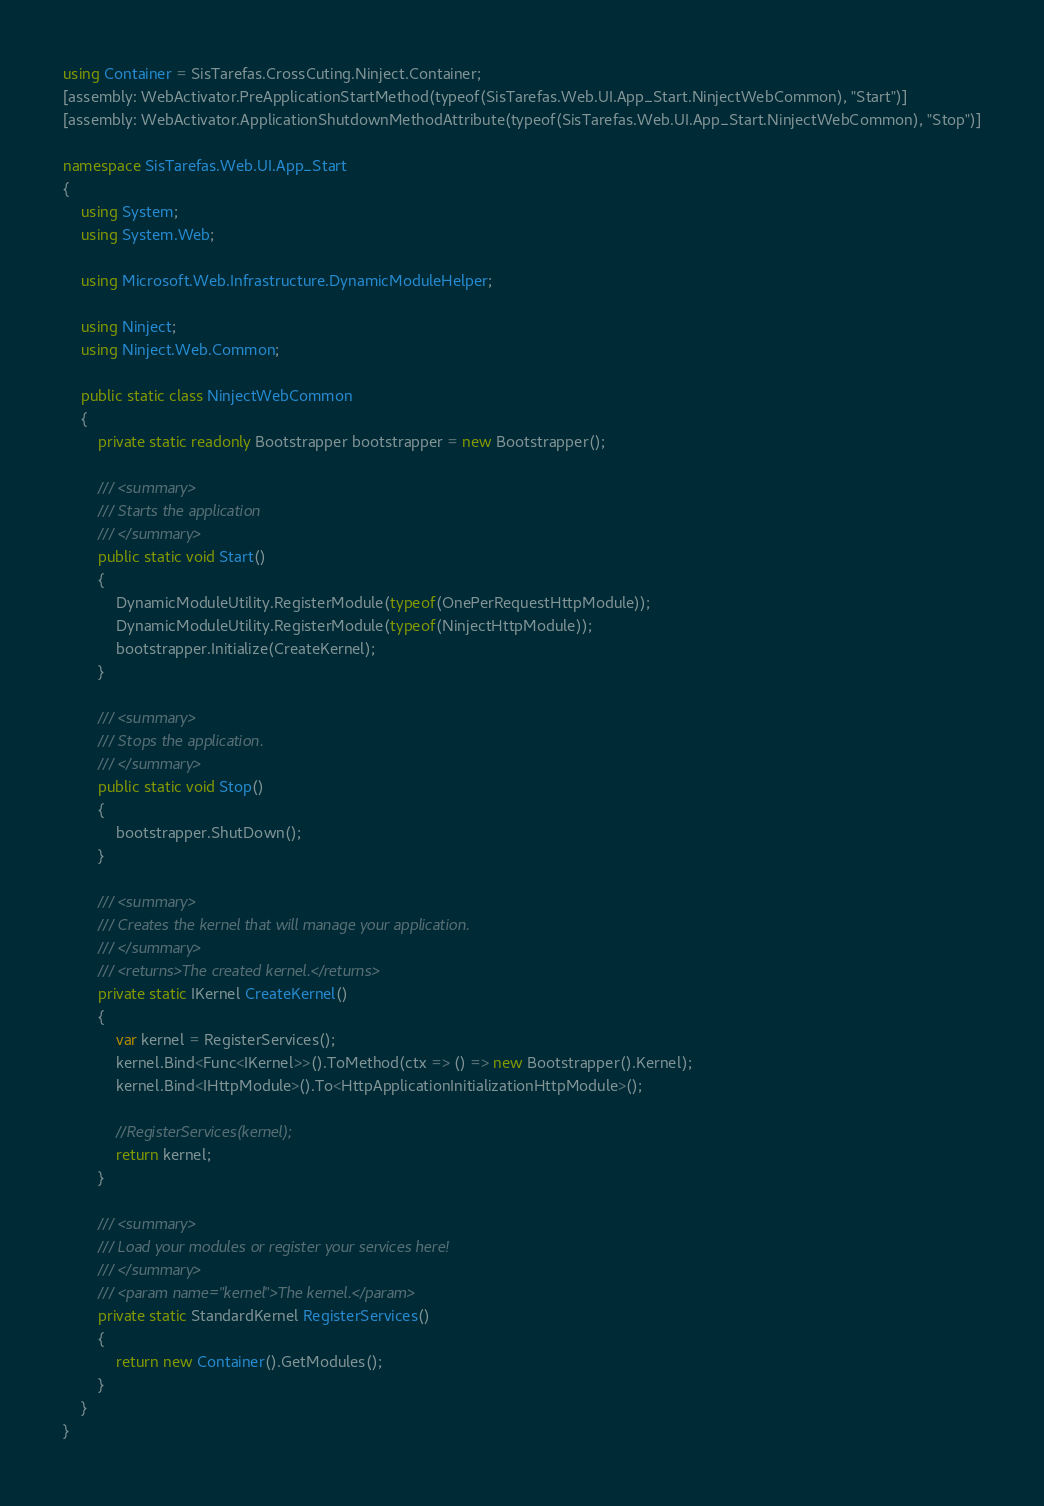<code> <loc_0><loc_0><loc_500><loc_500><_C#_>using Container = SisTarefas.CrossCuting.Ninject.Container;
[assembly: WebActivator.PreApplicationStartMethod(typeof(SisTarefas.Web.UI.App_Start.NinjectWebCommon), "Start")]
[assembly: WebActivator.ApplicationShutdownMethodAttribute(typeof(SisTarefas.Web.UI.App_Start.NinjectWebCommon), "Stop")]

namespace SisTarefas.Web.UI.App_Start
{
    using System;
    using System.Web;

    using Microsoft.Web.Infrastructure.DynamicModuleHelper;

    using Ninject;
    using Ninject.Web.Common;

    public static class NinjectWebCommon 
    {
        private static readonly Bootstrapper bootstrapper = new Bootstrapper();

        /// <summary>
        /// Starts the application
        /// </summary>
        public static void Start() 
        {
            DynamicModuleUtility.RegisterModule(typeof(OnePerRequestHttpModule));
            DynamicModuleUtility.RegisterModule(typeof(NinjectHttpModule));
            bootstrapper.Initialize(CreateKernel);
        }
        
        /// <summary>
        /// Stops the application.
        /// </summary>
        public static void Stop()
        {
            bootstrapper.ShutDown();
        }
        
        /// <summary>
        /// Creates the kernel that will manage your application.
        /// </summary>
        /// <returns>The created kernel.</returns>
        private static IKernel CreateKernel()
        {
            var kernel = RegisterServices();
            kernel.Bind<Func<IKernel>>().ToMethod(ctx => () => new Bootstrapper().Kernel);
            kernel.Bind<IHttpModule>().To<HttpApplicationInitializationHttpModule>();
            
            //RegisterServices(kernel);
            return kernel;
        }

        /// <summary>
        /// Load your modules or register your services here!
        /// </summary>
        /// <param name="kernel">The kernel.</param>
        private static StandardKernel RegisterServices()
        {
            return new Container().GetModules();
        }        
    }
}
</code> 